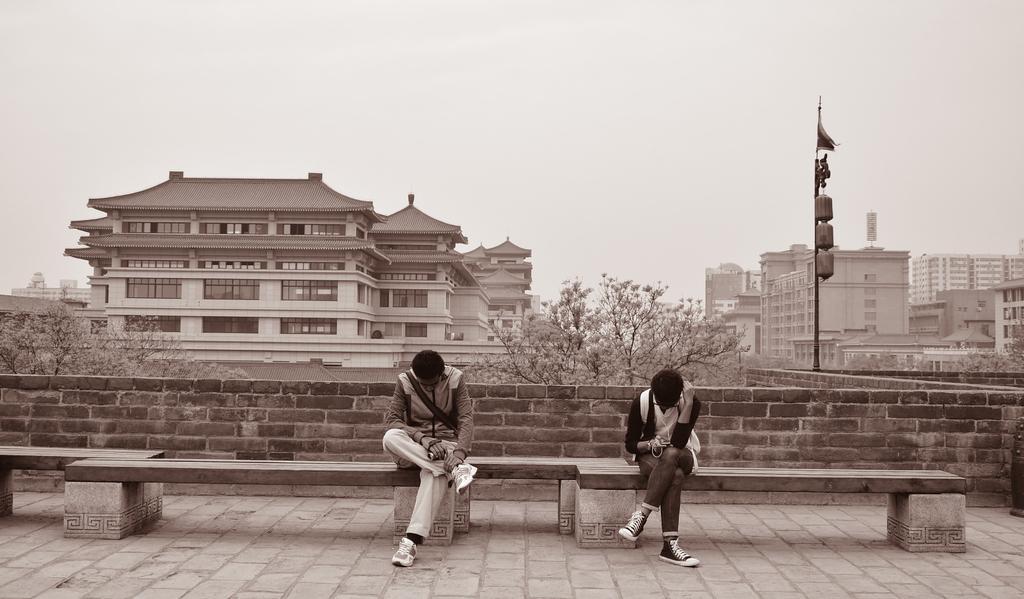Please provide a concise description of this image. In this image, we can see two people are sitting on the bench. At the bottom, there is a walkway. Background we can see brick wall, trees poles, buildings, walls, windows, glass objects, few things, flag and sky. 